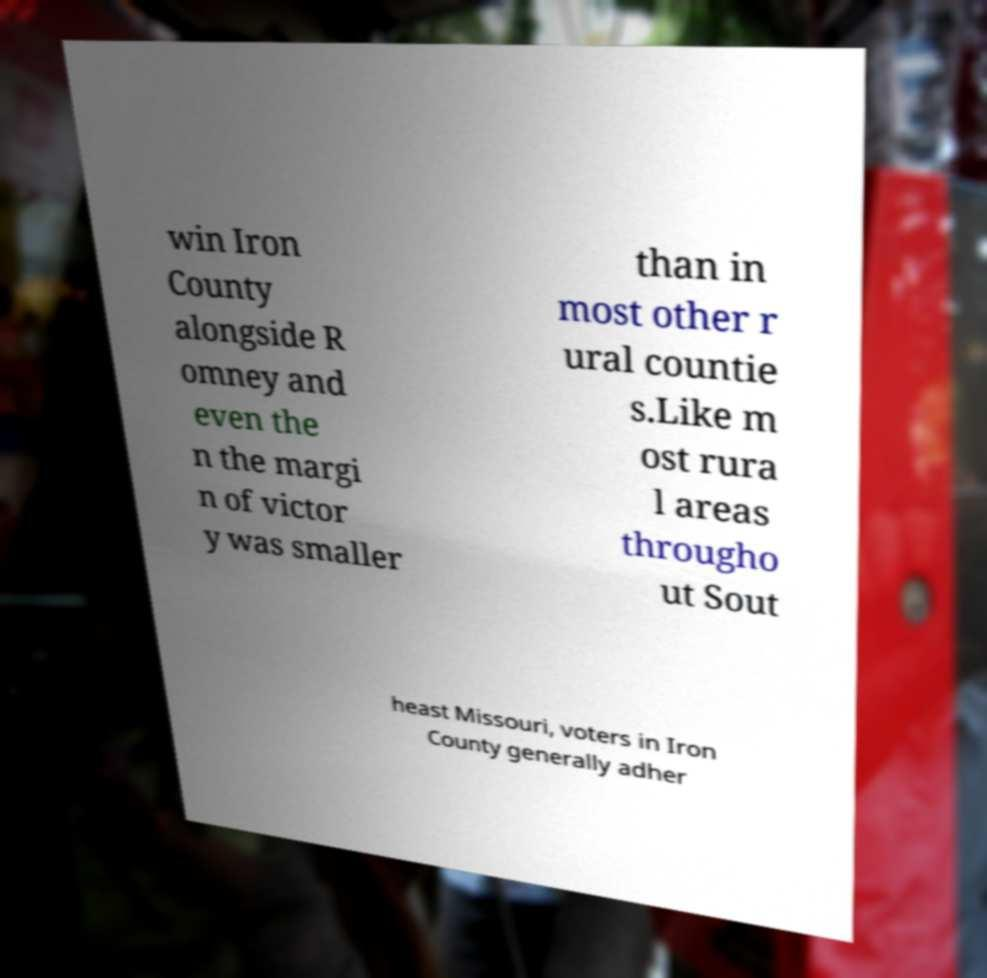Please read and relay the text visible in this image. What does it say? win Iron County alongside R omney and even the n the margi n of victor y was smaller than in most other r ural countie s.Like m ost rura l areas througho ut Sout heast Missouri, voters in Iron County generally adher 